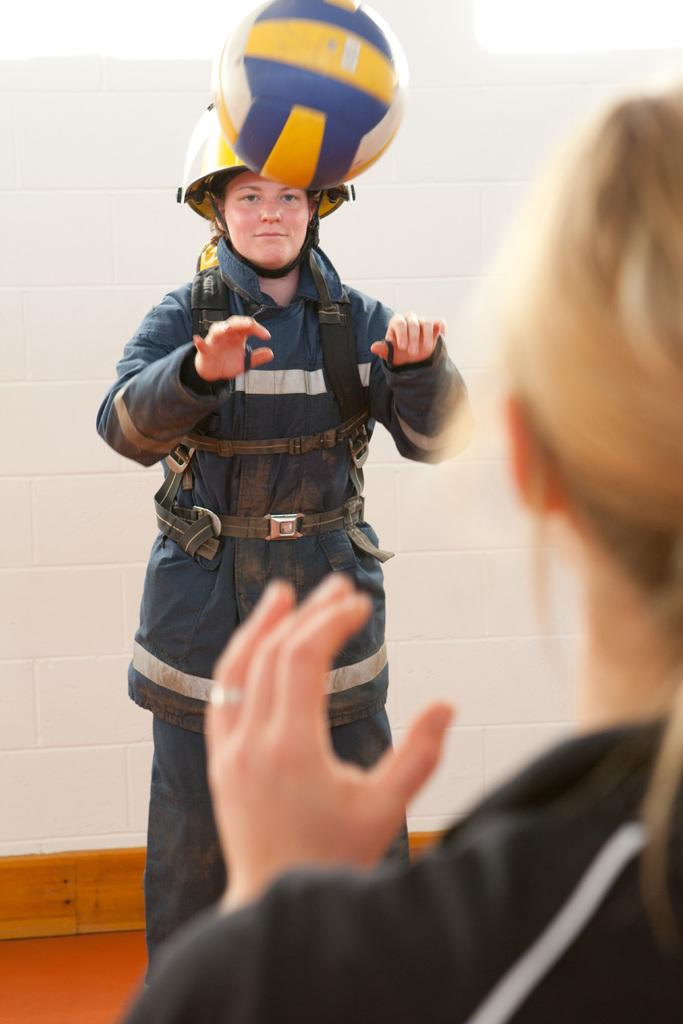How many people are in the image? There are two people in the image. Can you describe one of the people in the image? One of the people is a woman. What is the woman wearing in the image? The woman is wearing a helmet and suit. What is happening in the image? There is a ball in the air. What can be seen in the background of the image? There is a white color wall in the background of the image. What type of sound can be heard coming from the top of the wall in the image? There is no sound present in the image, and the wall does not have a top. --- Facts: 1. There is a car in the image. 2. The car is red. 3. The car has four wheels. 4. There is a road in the image. 5. The road is paved. Absurd Topics: ocean, birds, sand Conversation: What is the main subject of the image? The main subject of the image is a car. Can you describe the car in the image? The car is red and has four wheels. What is the car situated on in the image? The car is on a road. What type of road is in the image? The road is paved. Reasoning: Let's think step by step in order to produce the conversation. We start by identifying the main subject of the image, which is the car. Then, we describe the car's color and the number of wheels it has. Next, we mention the car's location, which is on a road. Finally, we describe the road's condition, which is paved. Absurd Question/Answer: How many birds can be seen flying over the ocean in the image? There is no ocean or birds present in the image; it features a red car on a paved road. 